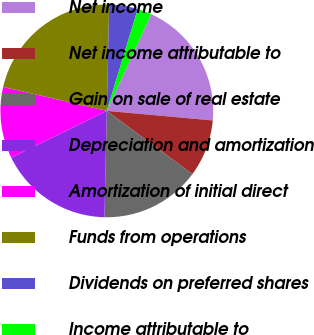Convert chart to OTSL. <chart><loc_0><loc_0><loc_500><loc_500><pie_chart><fcel>Net income<fcel>Net income attributable to<fcel>Gain on sale of real estate<fcel>Depreciation and amortization<fcel>Amortization of initial direct<fcel>Funds from operations<fcel>Dividends on preferred shares<fcel>Income attributable to<nl><fcel>19.57%<fcel>8.7%<fcel>15.22%<fcel>17.39%<fcel>10.87%<fcel>21.74%<fcel>4.35%<fcel>2.17%<nl></chart> 